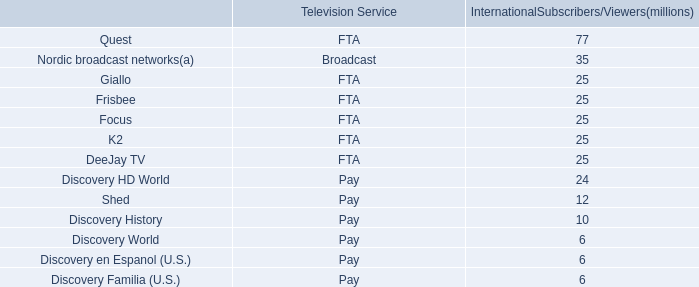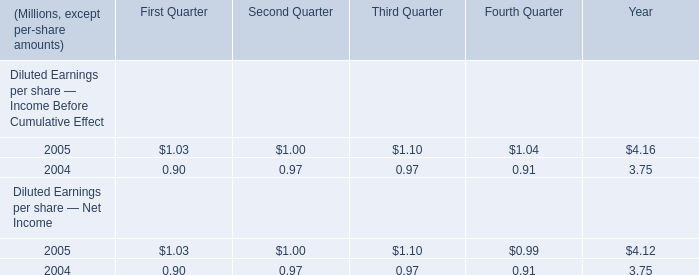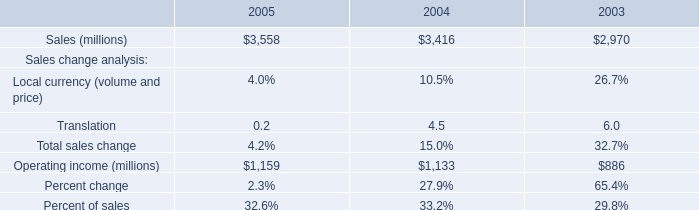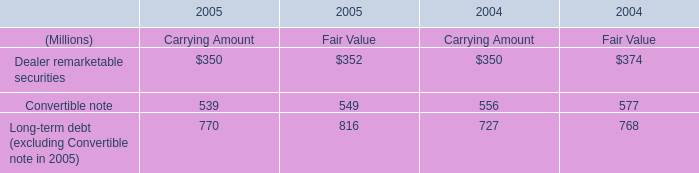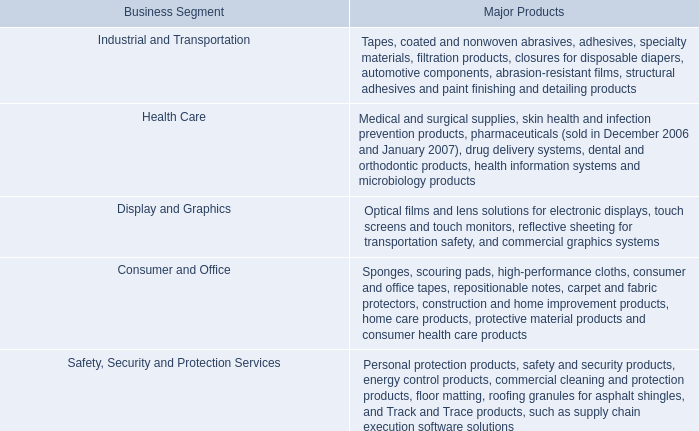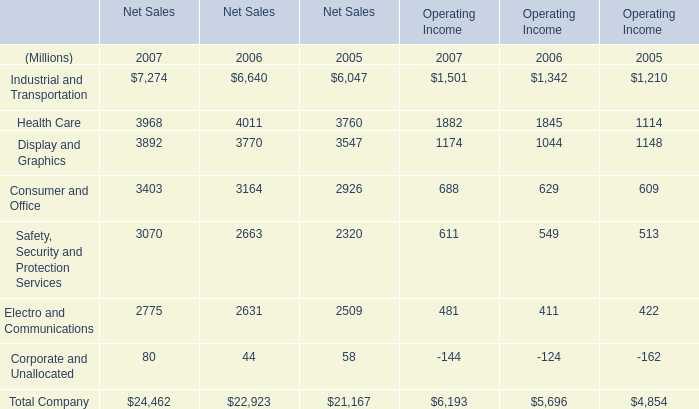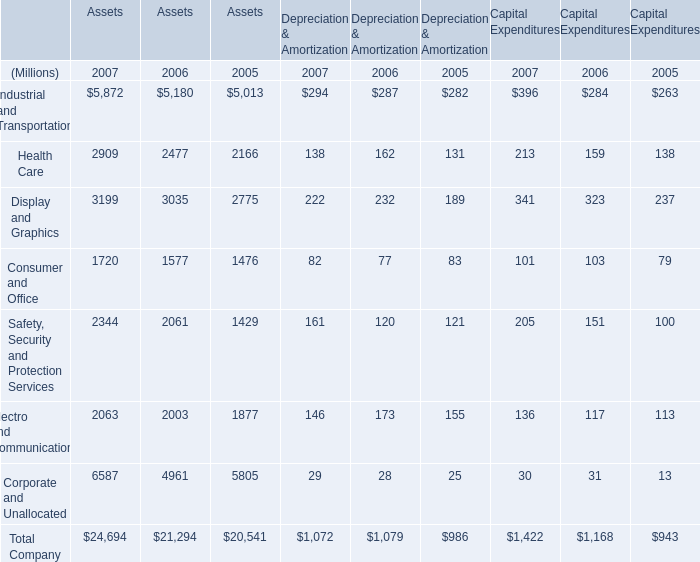what's the total amount of Health Care of Assets 2005, Consumer and Office of Net Sales 2006, and Total Company of Net Sales 2006 ? 
Computations: ((2166.0 + 3164.0) + 22923.0)
Answer: 28253.0. 